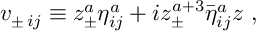Convert formula to latex. <formula><loc_0><loc_0><loc_500><loc_500>v _ { \pm \, i j } \equiv z _ { \pm } ^ { a } { \eta } _ { i j } ^ { a } + i z _ { \pm } ^ { a + 3 } { \bar { \eta } } _ { i j } ^ { a } z \ ,</formula> 